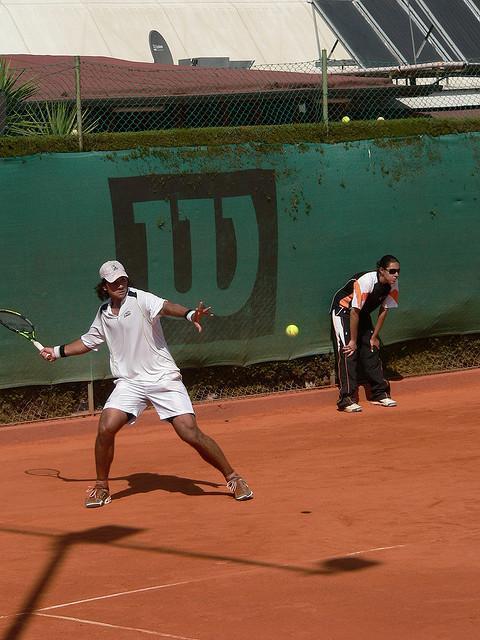How many people are in the picture?
Give a very brief answer. 2. 